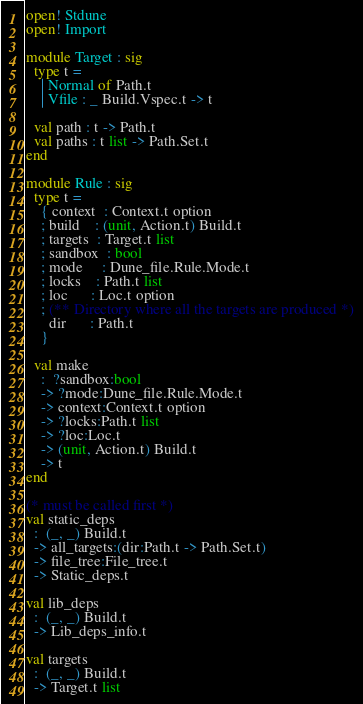<code> <loc_0><loc_0><loc_500><loc_500><_OCaml_>open! Stdune
open! Import

module Target : sig
  type t =
    | Normal of Path.t
    | Vfile : _ Build.Vspec.t -> t

  val path : t -> Path.t
  val paths : t list -> Path.Set.t
end

module Rule : sig
  type t =
    { context  : Context.t option
    ; build    : (unit, Action.t) Build.t
    ; targets  : Target.t list
    ; sandbox  : bool
    ; mode     : Dune_file.Rule.Mode.t
    ; locks    : Path.t list
    ; loc      : Loc.t option
    ; (** Directory where all the targets are produced *)
      dir      : Path.t
    }

  val make
    :  ?sandbox:bool
    -> ?mode:Dune_file.Rule.Mode.t
    -> context:Context.t option
    -> ?locks:Path.t list
    -> ?loc:Loc.t
    -> (unit, Action.t) Build.t
    -> t
end

(* must be called first *)
val static_deps
  :  (_, _) Build.t
  -> all_targets:(dir:Path.t -> Path.Set.t)
  -> file_tree:File_tree.t
  -> Static_deps.t

val lib_deps
  :  (_, _) Build.t
  -> Lib_deps_info.t

val targets
  :  (_, _) Build.t
  -> Target.t list
</code> 